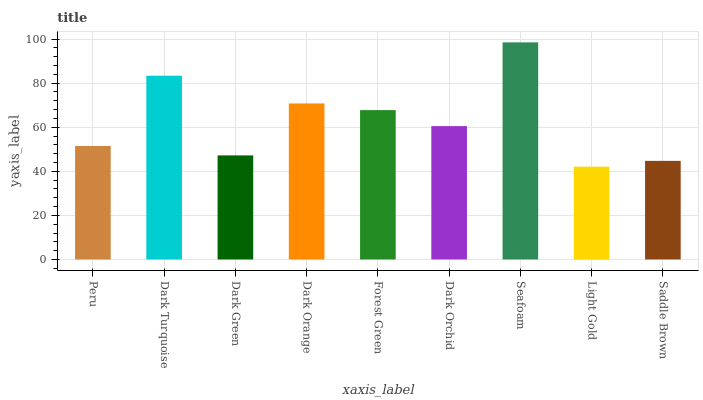Is Light Gold the minimum?
Answer yes or no. Yes. Is Seafoam the maximum?
Answer yes or no. Yes. Is Dark Turquoise the minimum?
Answer yes or no. No. Is Dark Turquoise the maximum?
Answer yes or no. No. Is Dark Turquoise greater than Peru?
Answer yes or no. Yes. Is Peru less than Dark Turquoise?
Answer yes or no. Yes. Is Peru greater than Dark Turquoise?
Answer yes or no. No. Is Dark Turquoise less than Peru?
Answer yes or no. No. Is Dark Orchid the high median?
Answer yes or no. Yes. Is Dark Orchid the low median?
Answer yes or no. Yes. Is Saddle Brown the high median?
Answer yes or no. No. Is Seafoam the low median?
Answer yes or no. No. 